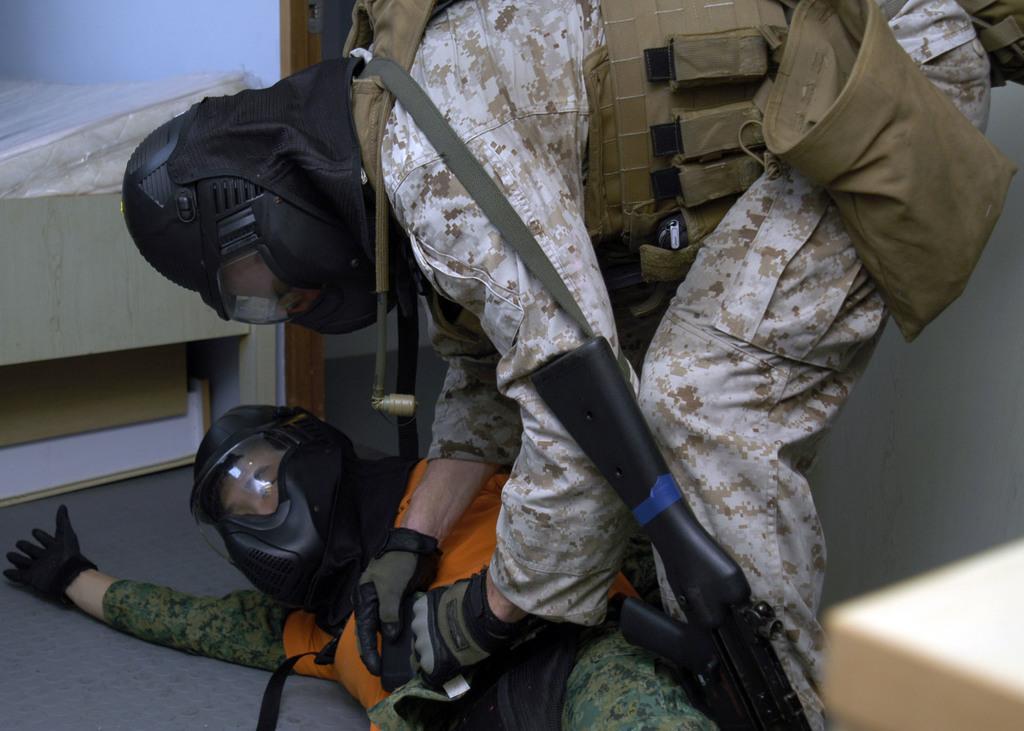How would you summarize this image in a sentence or two? In this image there are two people in the uniform wearing bags and holding guns, there is a bed, a box under the bed and a desk. 